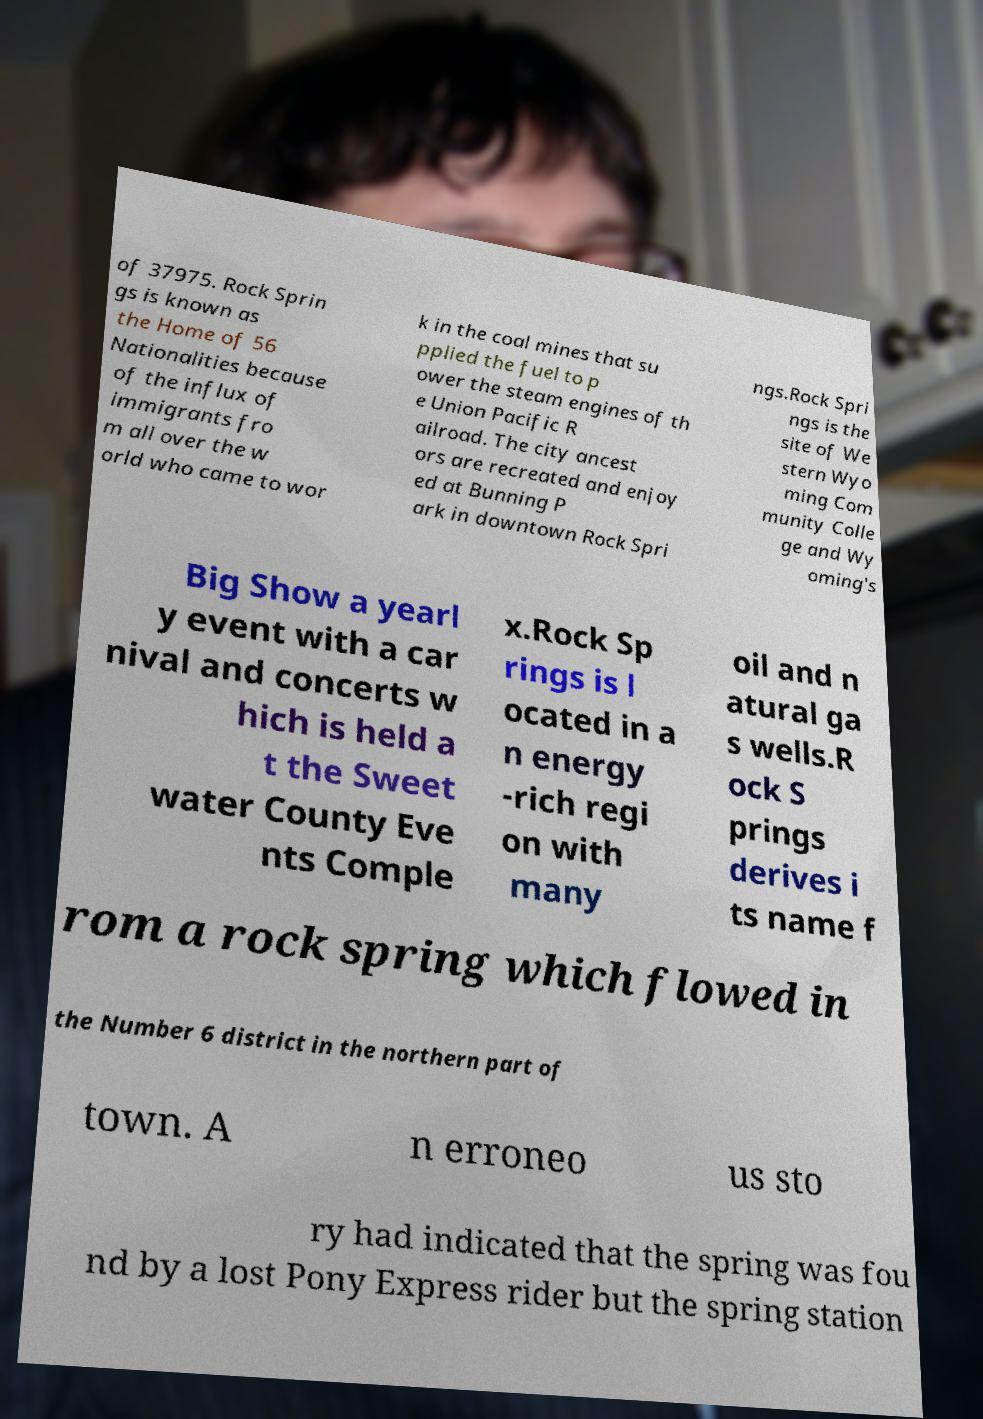I need the written content from this picture converted into text. Can you do that? of 37975. Rock Sprin gs is known as the Home of 56 Nationalities because of the influx of immigrants fro m all over the w orld who came to wor k in the coal mines that su pplied the fuel to p ower the steam engines of th e Union Pacific R ailroad. The city ancest ors are recreated and enjoy ed at Bunning P ark in downtown Rock Spri ngs.Rock Spri ngs is the site of We stern Wyo ming Com munity Colle ge and Wy oming's Big Show a yearl y event with a car nival and concerts w hich is held a t the Sweet water County Eve nts Comple x.Rock Sp rings is l ocated in a n energy -rich regi on with many oil and n atural ga s wells.R ock S prings derives i ts name f rom a rock spring which flowed in the Number 6 district in the northern part of town. A n erroneo us sto ry had indicated that the spring was fou nd by a lost Pony Express rider but the spring station 